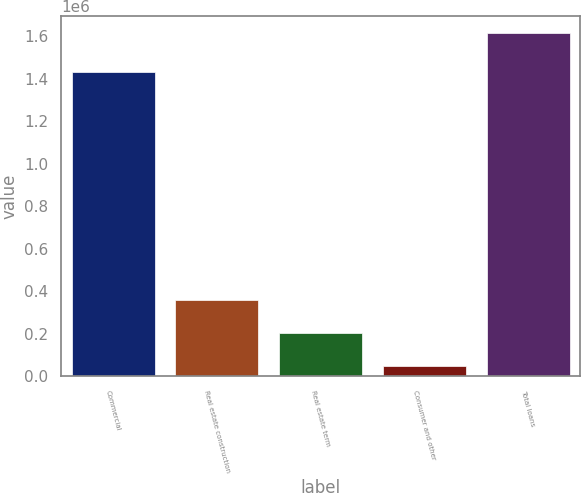Convert chart to OTSL. <chart><loc_0><loc_0><loc_500><loc_500><bar_chart><fcel>Commercial<fcel>Real estate construction<fcel>Real estate term<fcel>Consumer and other<fcel>Total loans<nl><fcel>1.42998e+06<fcel>360046<fcel>203561<fcel>47077<fcel>1.61192e+06<nl></chart> 